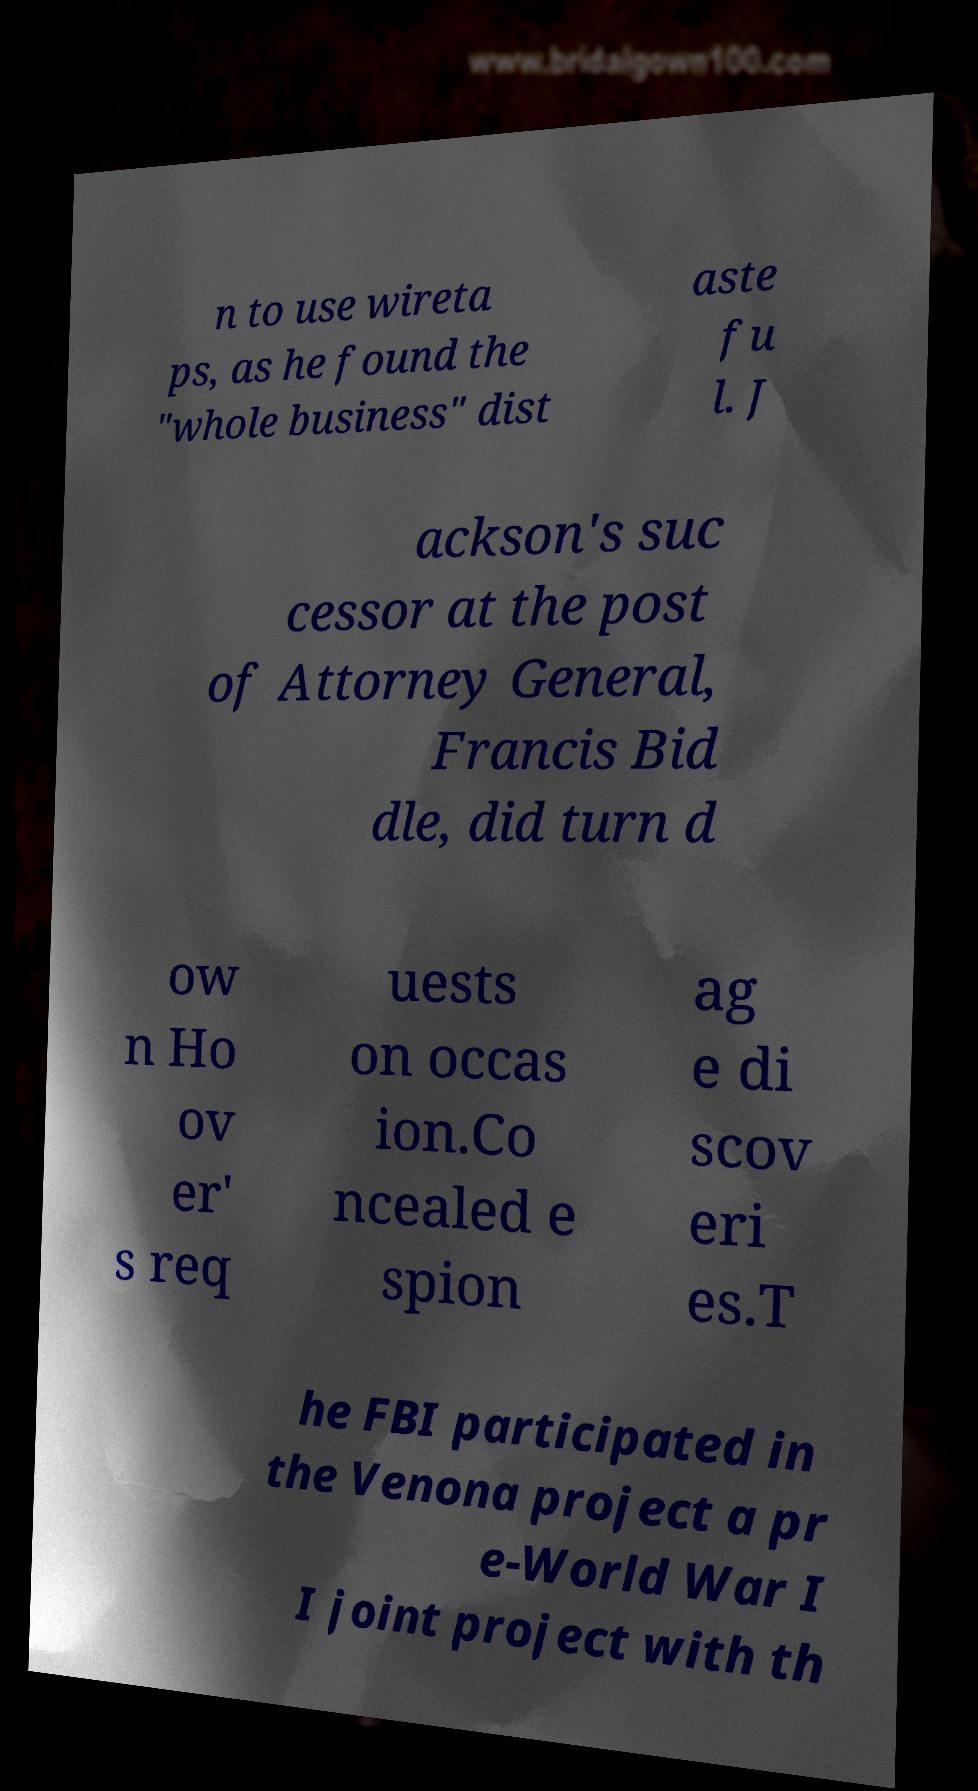Could you assist in decoding the text presented in this image and type it out clearly? n to use wireta ps, as he found the "whole business" dist aste fu l. J ackson's suc cessor at the post of Attorney General, Francis Bid dle, did turn d ow n Ho ov er' s req uests on occas ion.Co ncealed e spion ag e di scov eri es.T he FBI participated in the Venona project a pr e-World War I I joint project with th 